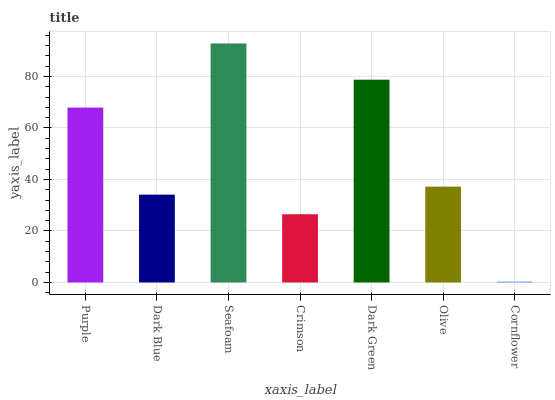Is Cornflower the minimum?
Answer yes or no. Yes. Is Seafoam the maximum?
Answer yes or no. Yes. Is Dark Blue the minimum?
Answer yes or no. No. Is Dark Blue the maximum?
Answer yes or no. No. Is Purple greater than Dark Blue?
Answer yes or no. Yes. Is Dark Blue less than Purple?
Answer yes or no. Yes. Is Dark Blue greater than Purple?
Answer yes or no. No. Is Purple less than Dark Blue?
Answer yes or no. No. Is Olive the high median?
Answer yes or no. Yes. Is Olive the low median?
Answer yes or no. Yes. Is Seafoam the high median?
Answer yes or no. No. Is Cornflower the low median?
Answer yes or no. No. 